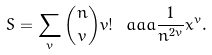<formula> <loc_0><loc_0><loc_500><loc_500>S = \sum _ { v } { n \choose v } v ! \ a a a \frac { 1 } { n ^ { 2 v } } x ^ { v } .</formula> 